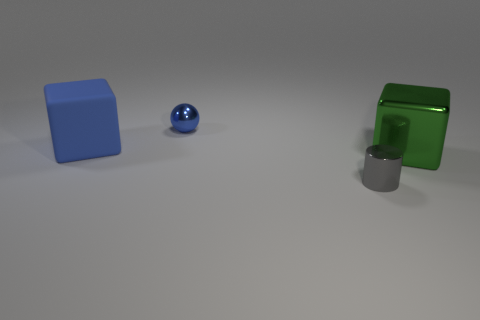Does the cube that is left of the tiny cylinder have the same material as the small thing that is to the left of the tiny gray cylinder?
Offer a terse response. No. How many other gray objects have the same shape as the gray object?
Your answer should be very brief. 0. What is the material of the tiny sphere that is the same color as the large rubber block?
Ensure brevity in your answer.  Metal. What number of objects are either green objects or large blocks that are behind the green block?
Offer a terse response. 2. What is the material of the big green thing?
Offer a terse response. Metal. There is another big object that is the same shape as the large shiny object; what is it made of?
Your response must be concise. Rubber. The cube that is on the right side of the small metal object that is in front of the large green object is what color?
Make the answer very short. Green. How many shiny things are big red things or big blue things?
Provide a succinct answer. 0. Do the tiny ball and the large green thing have the same material?
Offer a terse response. Yes. There is a tiny object behind the big thing in front of the matte object; what is it made of?
Your response must be concise. Metal. 